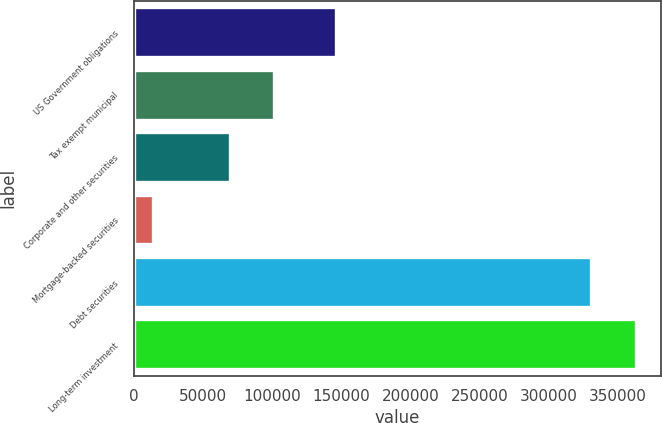Convert chart. <chart><loc_0><loc_0><loc_500><loc_500><bar_chart><fcel>US Government obligations<fcel>Tax exempt municipal<fcel>Corporate and other securities<fcel>Mortgage-backed securities<fcel>Debt securities<fcel>Long-term investment<nl><fcel>146221<fcel>101552<fcel>69514<fcel>14258<fcel>330870<fcel>362908<nl></chart> 